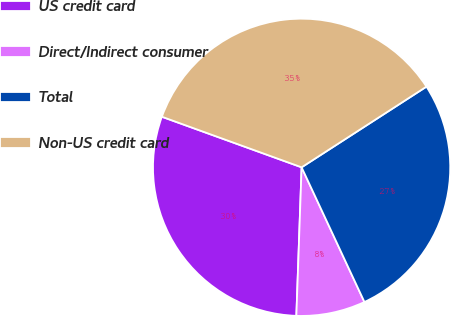Convert chart. <chart><loc_0><loc_0><loc_500><loc_500><pie_chart><fcel>US credit card<fcel>Direct/Indirect consumer<fcel>Total<fcel>Non-US credit card<nl><fcel>29.96%<fcel>7.51%<fcel>27.18%<fcel>35.34%<nl></chart> 